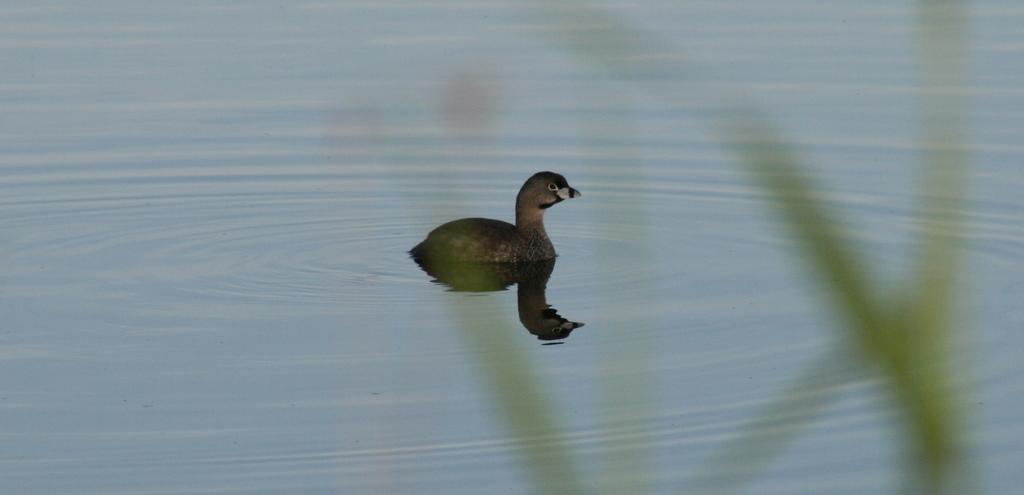What animal is present in the image? There is a duck in the image. What is the duck doing in the image? The duck is swimming in the water. What other object can be seen in the image besides the duck? There is a plant in the image. How many slaves are visible in the image? There are no slaves present in the image; it features a duck swimming in the water and a plant. What type of bead is being used as a decoration in the image? There is no bead present in the image. 